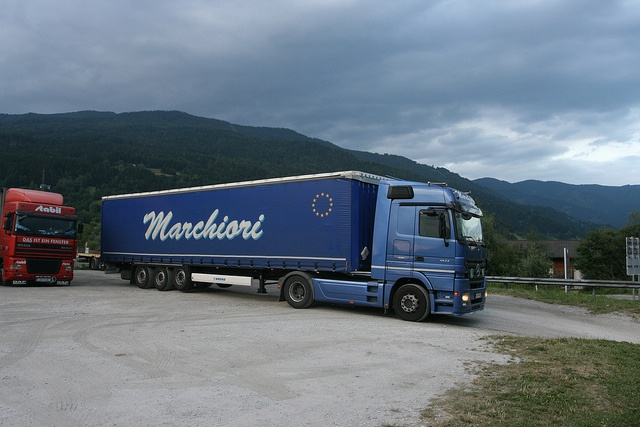Describe the objects in this image and their specific colors. I can see truck in darkgray, navy, black, darkblue, and gray tones and truck in darkgray, black, maroon, brown, and gray tones in this image. 